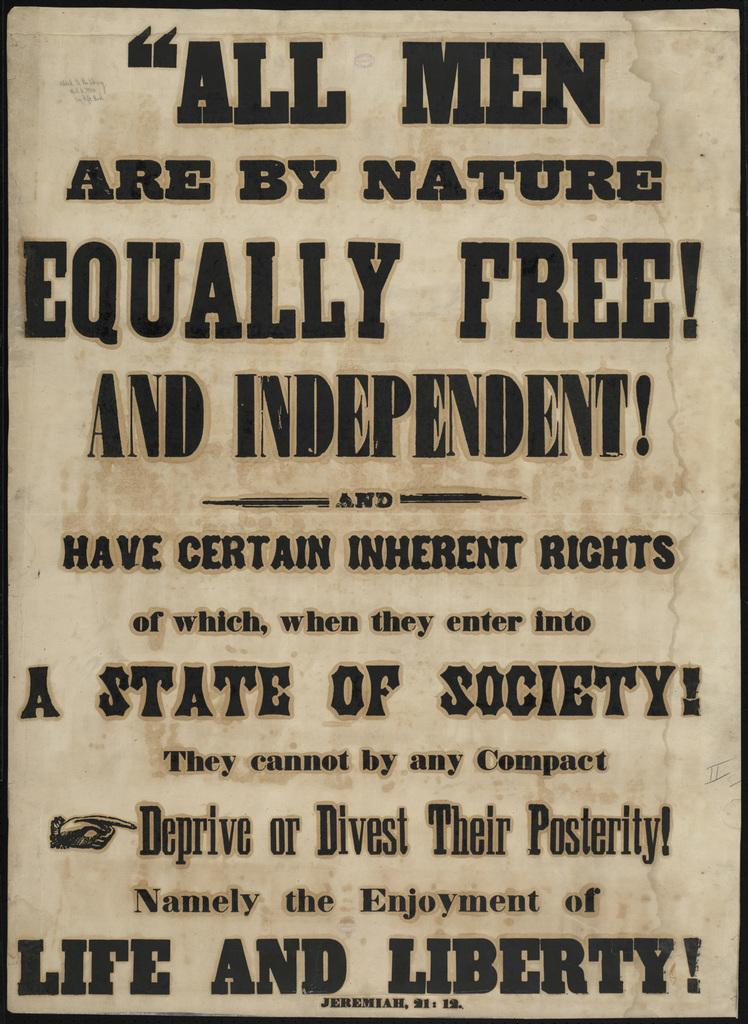<image>
Share a concise interpretation of the image provided. All men are by nature equally free and independent! 